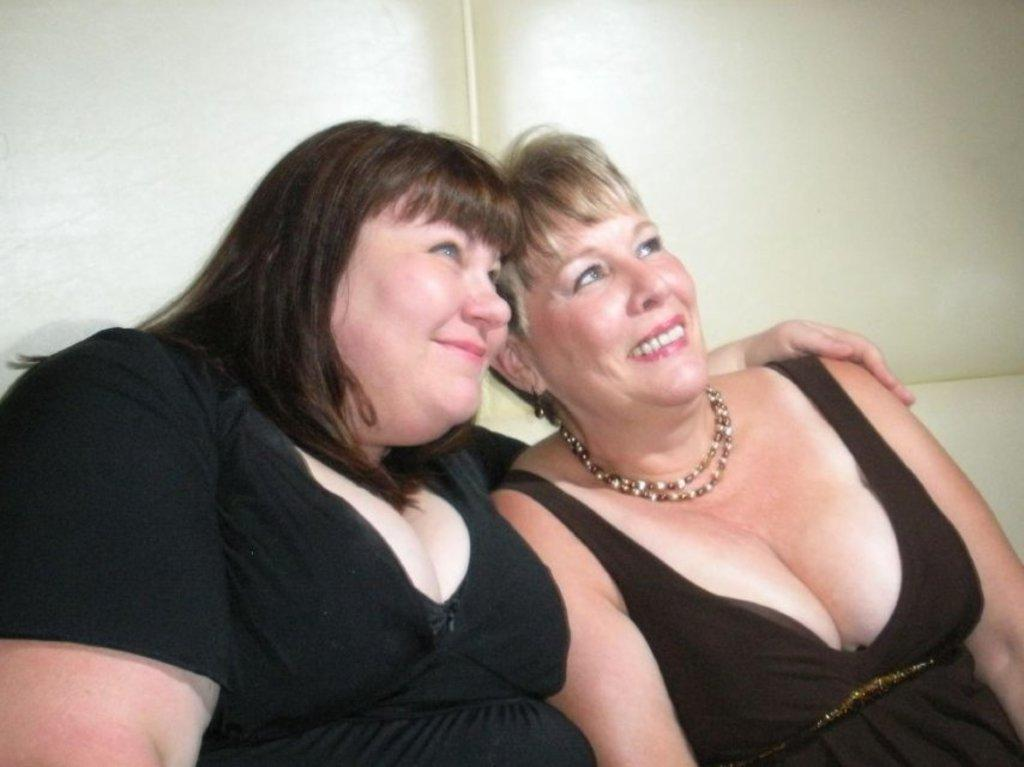How many people are in the image? There are two people in the image. What are the people doing in the image? The two people are sitting on a couch. What expressions do the people have in the image? The people have smiles on their faces. What type of polish is being applied to the club in the image? There is no club or polish present in the image; it features two people sitting on a couch with smiles on their faces. 